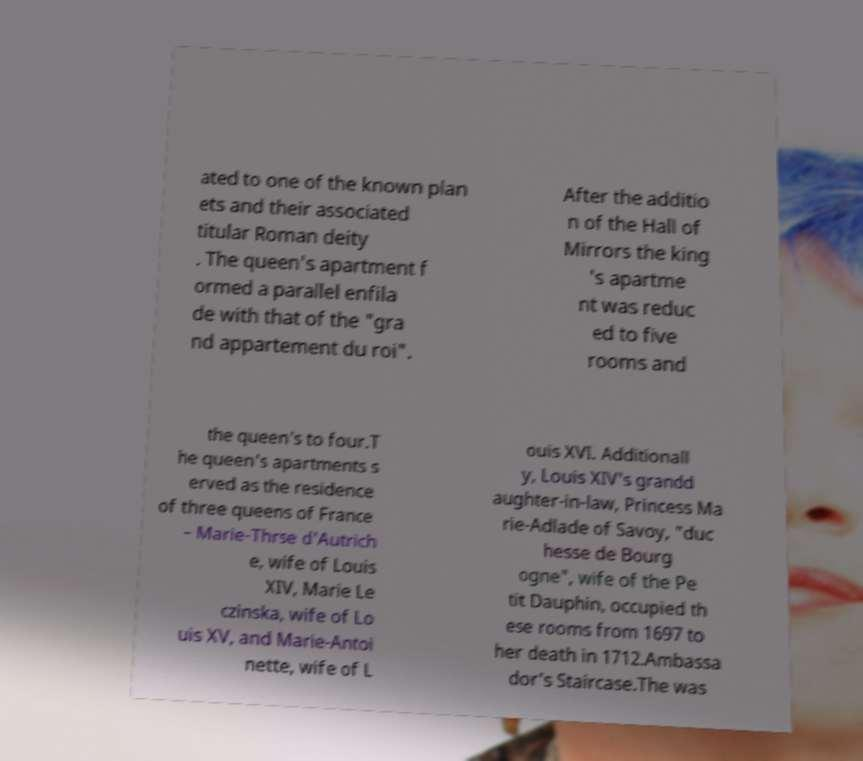Can you read and provide the text displayed in the image?This photo seems to have some interesting text. Can you extract and type it out for me? ated to one of the known plan ets and their associated titular Roman deity . The queen's apartment f ormed a parallel enfila de with that of the "gra nd appartement du roi". After the additio n of the Hall of Mirrors the king 's apartme nt was reduc ed to five rooms and the queen's to four.T he queen's apartments s erved as the residence of three queens of France – Marie-Thrse d'Autrich e, wife of Louis XIV, Marie Le czinska, wife of Lo uis XV, and Marie-Antoi nette, wife of L ouis XVI. Additionall y, Louis XIV's grandd aughter-in-law, Princess Ma rie-Adlade of Savoy, "duc hesse de Bourg ogne", wife of the Pe tit Dauphin, occupied th ese rooms from 1697 to her death in 1712.Ambassa dor's Staircase.The was 